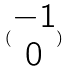Convert formula to latex. <formula><loc_0><loc_0><loc_500><loc_500>( \begin{matrix} - 1 \\ 0 \end{matrix} )</formula> 